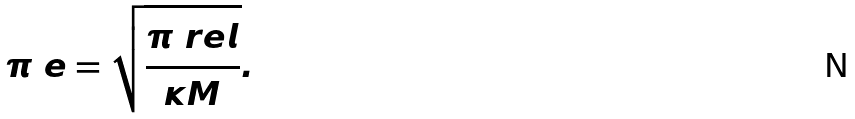<formula> <loc_0><loc_0><loc_500><loc_500>\pi _ { \ } e = \sqrt { \frac { \pi _ { \ } r e l } { \kappa M } } .</formula> 